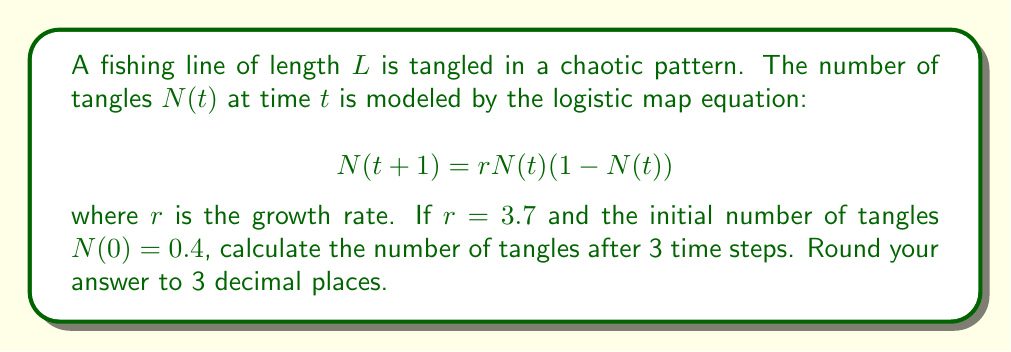Teach me how to tackle this problem. To solve this problem, we need to apply the logistic map equation iteratively for 3 time steps:

Step 1: Calculate $N(1)$
$$N(1) = 3.7 \cdot 0.4 \cdot (1-0.4) = 3.7 \cdot 0.4 \cdot 0.6 = 0.888$$

Step 2: Calculate $N(2)$
$$N(2) = 3.7 \cdot 0.888 \cdot (1-0.888) = 3.7 \cdot 0.888 \cdot 0.112 = 0.368$$

Step 3: Calculate $N(3)$
$$N(3) = 3.7 \cdot 0.368 \cdot (1-0.368) = 3.7 \cdot 0.368 \cdot 0.632 = 0.863$$

Step 4: Round the result to 3 decimal places
$0.863$ rounded to 3 decimal places is $0.863$.
Answer: 0.863 